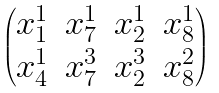<formula> <loc_0><loc_0><loc_500><loc_500>\begin{pmatrix} x _ { 1 } ^ { 1 } & x _ { 7 } ^ { 1 } & x _ { 2 } ^ { 1 } & x _ { 8 } ^ { 1 } \\ x _ { 4 } ^ { 1 } & x _ { 7 } ^ { 3 } & x _ { 2 } ^ { 3 } & x _ { 8 } ^ { 2 } \end{pmatrix}</formula> 